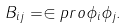Convert formula to latex. <formula><loc_0><loc_0><loc_500><loc_500>B _ { i j } = \in p r o { \phi _ { i } } { \phi _ { j } } .</formula> 